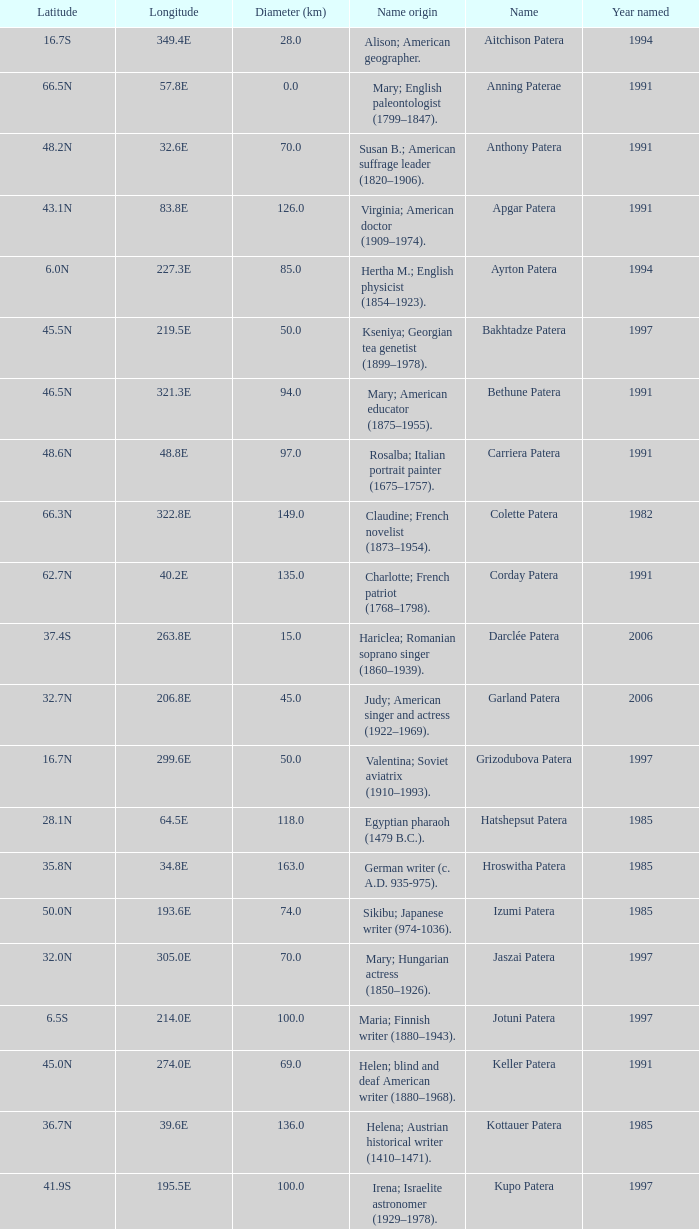In what year was the feature at a 33.3S latitude named?  2000.0. 